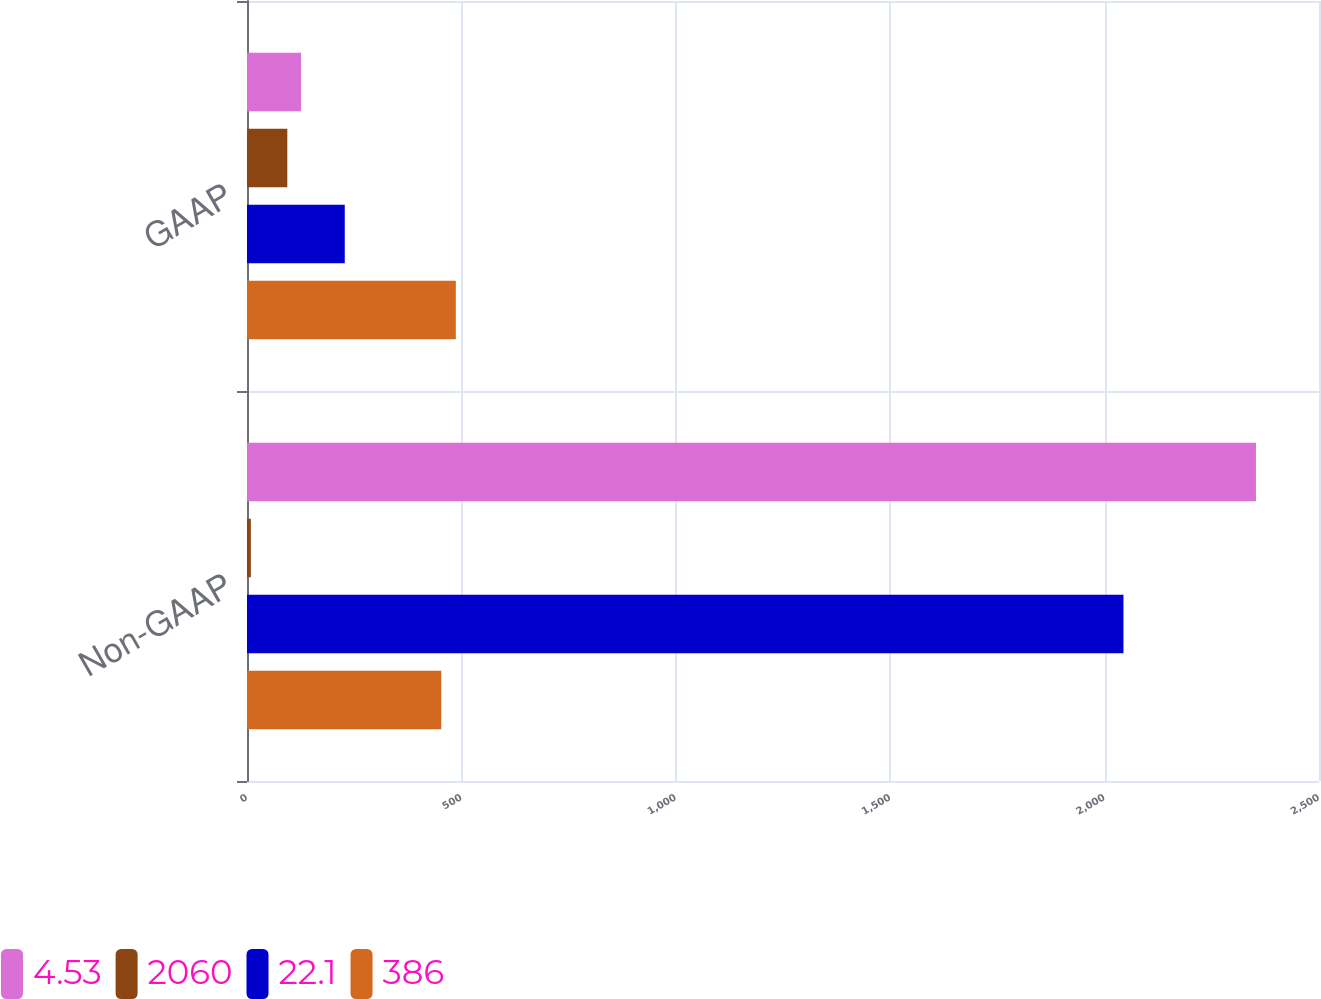Convert chart. <chart><loc_0><loc_0><loc_500><loc_500><stacked_bar_chart><ecel><fcel>Non-GAAP<fcel>GAAP<nl><fcel>4.53<fcel>2353<fcel>126<nl><fcel>2060<fcel>9<fcel>94<nl><fcel>22.1<fcel>2044<fcel>228<nl><fcel>386<fcel>453<fcel>487<nl></chart> 